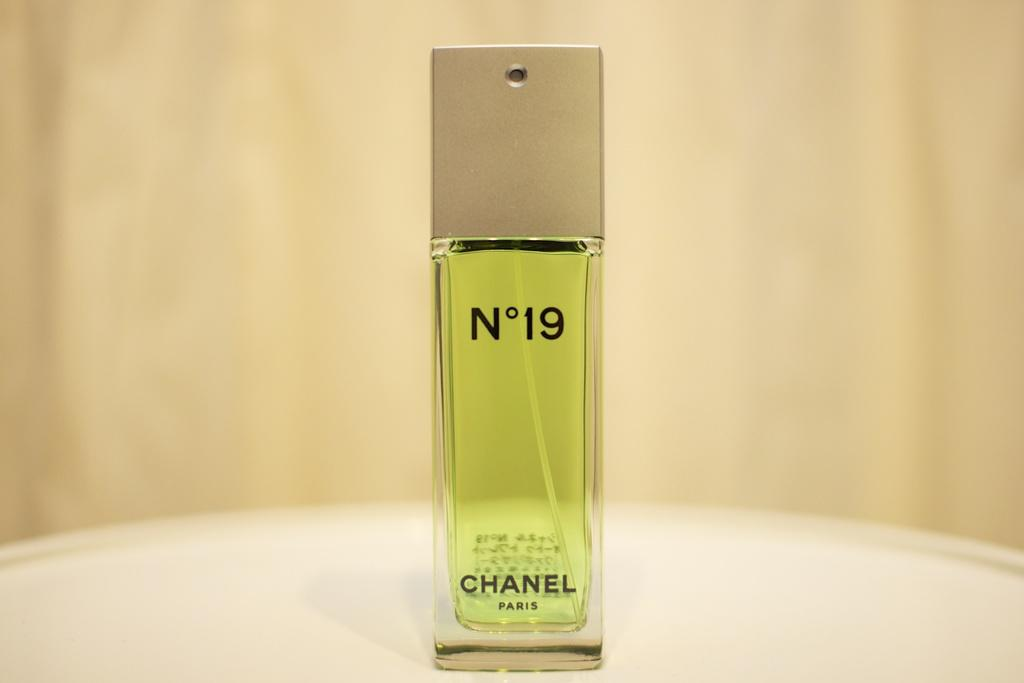What object is the main subject of the image? There is a perfume bottle in the image. Where is the perfume bottle located? The perfume bottle is placed on a table. What type of plastic material is used to make the quartz in the image? There is no plastic or quartz present in the image; it features a perfume bottle placed on a table. 